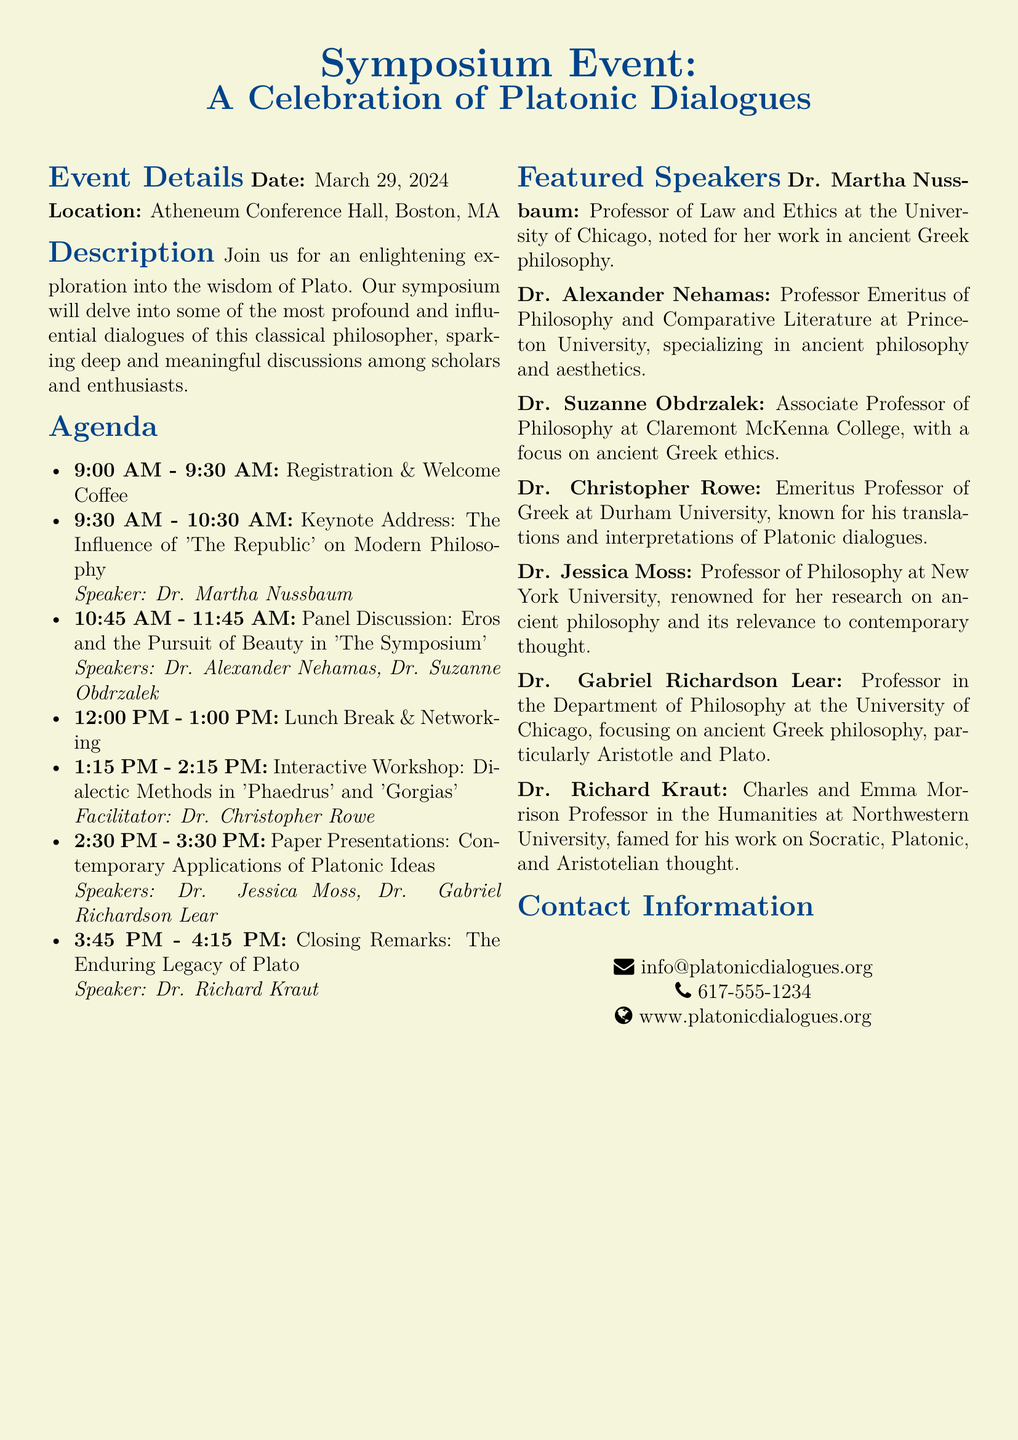What is the date of the event? The date of the event is mentioned in the document under Event Details.
Answer: March 29, 2024 Where is the symposium taking place? The location of the symposium is specified in the Event Details section.
Answer: Atheneum Conference Hall, Boston, MA Who is the keynote speaker? The document identifies the keynote speaker in the Agenda section.
Answer: Dr. Martha Nussbaum What is the topic of the keynote address? The topic of the keynote address is listed in the Agenda section.
Answer: The Influence of 'The Republic' on Modern Philosophy How many speakers are featured in the symposium? The Featured Speakers section lists the individuals participating in the event.
Answer: Seven What is the focus of Dr. Suzanne Obdrzalek's work? Dr. Suzanne Obdrzalek's area of focus is indicated in her speaker bio.
Answer: Ancient Greek ethics What time does the lunch break start? The lunch break time is mentioned in the Agenda section of the document.
Answer: 12:00 PM What is the theme of the panel discussion? The theme of the panel discussion is specified in the Agenda section.
Answer: Eros and the Pursuit of Beauty in 'The Symposium' 